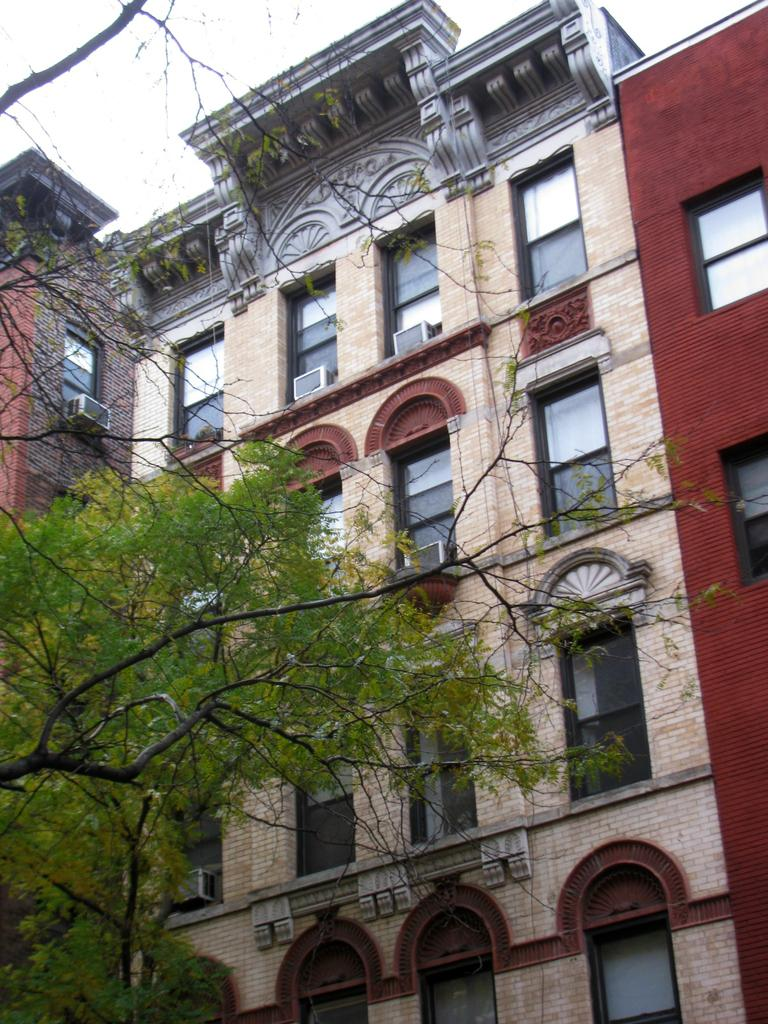What type of structure is visible in the image? There is a building in the image. What is located in front of the building? There is a tree in front of the building. Can you tell me how many butterflies are flying around the tree in the image? There are no butterflies visible in the image; it only shows a building and a tree. 